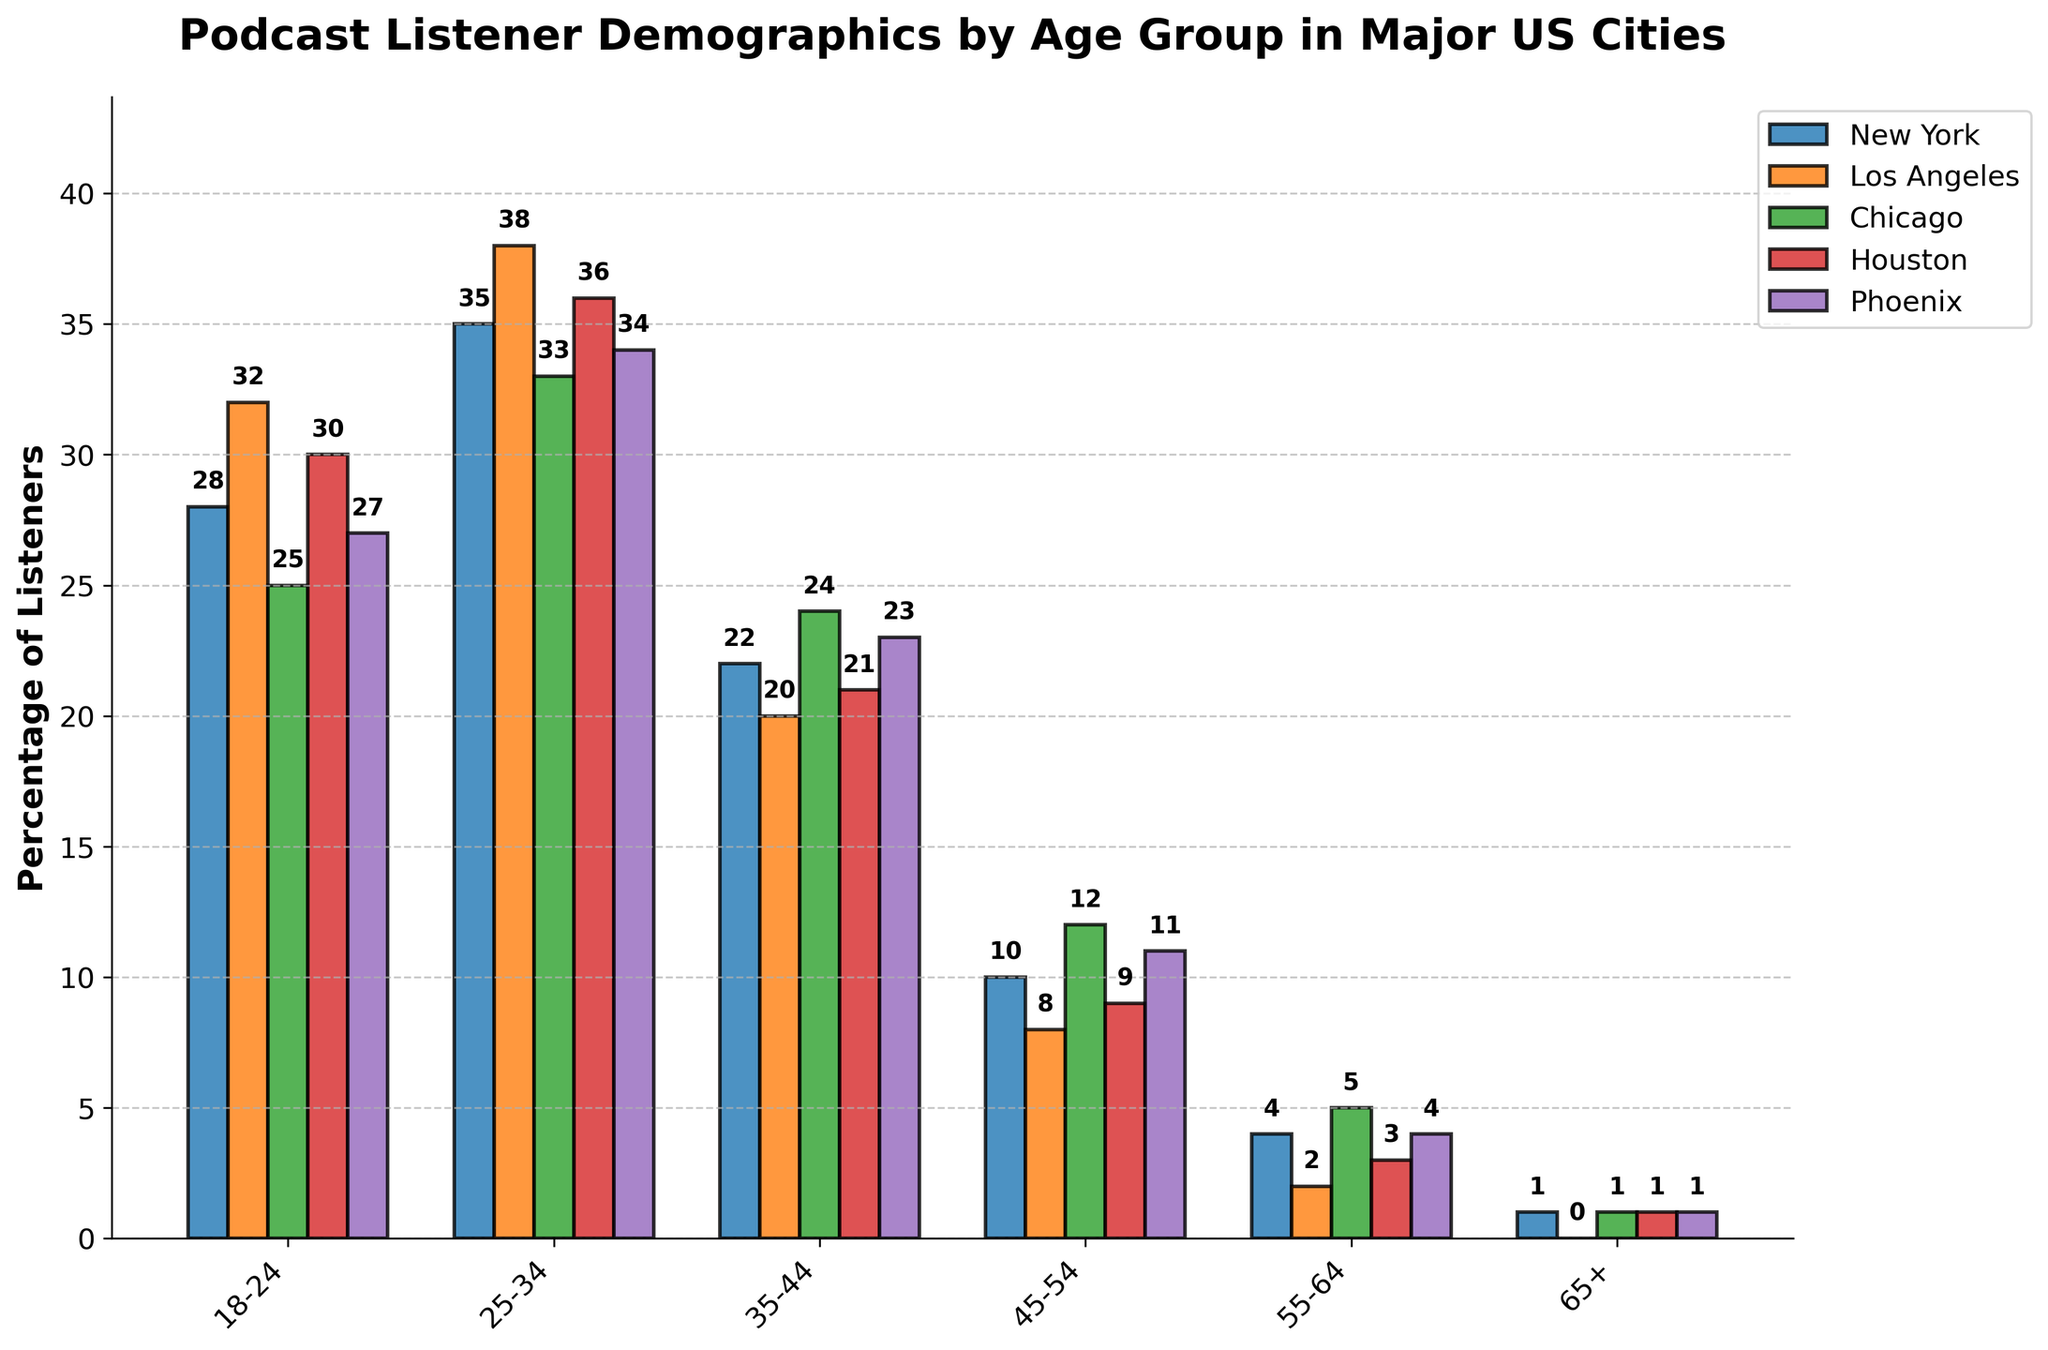What is the percentage of podcast listeners aged 18-24 in New York city? To find this, look at the height of the bar corresponding to the 18-24 age group for New York city. The height of this bar represents the percentage of listeners which is 28%.
Answer: 28% Which city has the highest percentage of listeners in the 25-34 age group? To determine this, compare the height of the bars for the 25-34 age group across all cities. The city with the tallest bar in this group is Los Angeles at 38%.
Answer: Los Angeles What is the difference in the number of listeners between the 18-24 and 25-34 age groups in Chicago? To calculate this, find the heights of the bars for both age groups in Chicago, then subtract the value of the 18-24 age group (25%) from the 25-34 age group (33%). `33 - 25 = 8`.
Answer: 8% Which age group in Phoenix has the lowest percentage of podcast listeners? Observe the bars for all age groups in Phoenix and identify the smallest bar, which corresponds to the age group 65+ with 1%.
Answer: 65+ What is the average percentage of listeners aged 35-44 across all cities? To calculate the average, sum up the percentages for the 35-44 age group in each city and then divide by the total number of cities. ` (22+20+24+21+23) / 5 = 22`.
Answer: 22% Which city has the lowest percentage of listeners aged 55-64? Compare the heights of the bars for the age group 55-64 across all cities. Los Angeles has the lowest percentage with 2%.
Answer: Los Angeles How many age groups in Houston have more than 20% podcast listeners? Examine the bars for Houston and count the number of age groups with a value over 20%. There are two such groups: 18-24 and 25-34.
Answer: 2 What is the combined percentage of podcast listeners aged 25-34 and 35-44 in Phoenix? Add the percentages for the 25-34 and 35-44 age groups in Phoenix: `34 + 23 = 57`.
Answer: 57% Which age group has a consistent percentage (same value) of podcast listeners across all cities? Identify the age group where the bars across all cities are the same height. The group 65+ has a percentage of 1% in all cities.
Answer: 65+ What is the overall percentage of listeners aged 45-54 in New York and Los Angeles combined? Add the percentages of the 45-54 age group in New York and Los Angeles: `10 + 8 = 18`.
Answer: 18% 